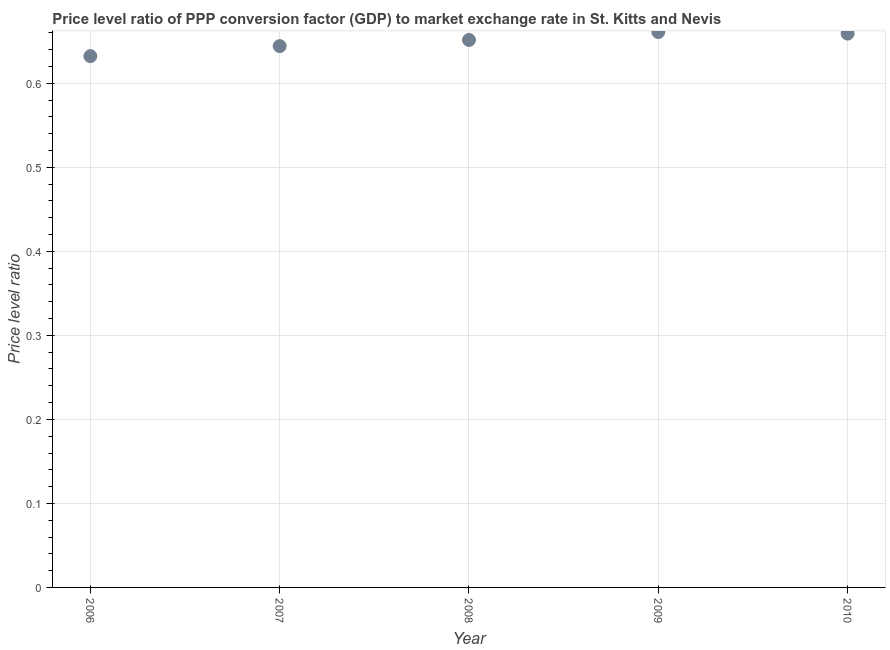What is the price level ratio in 2010?
Offer a very short reply. 0.66. Across all years, what is the maximum price level ratio?
Your answer should be compact. 0.66. Across all years, what is the minimum price level ratio?
Ensure brevity in your answer.  0.63. What is the sum of the price level ratio?
Provide a succinct answer. 3.25. What is the difference between the price level ratio in 2006 and 2007?
Provide a succinct answer. -0.01. What is the average price level ratio per year?
Provide a succinct answer. 0.65. What is the median price level ratio?
Your answer should be compact. 0.65. In how many years, is the price level ratio greater than 0.54 ?
Ensure brevity in your answer.  5. Do a majority of the years between 2006 and 2008 (inclusive) have price level ratio greater than 0.26 ?
Your answer should be compact. Yes. What is the ratio of the price level ratio in 2007 to that in 2008?
Provide a short and direct response. 0.99. Is the price level ratio in 2007 less than that in 2010?
Give a very brief answer. Yes. What is the difference between the highest and the second highest price level ratio?
Ensure brevity in your answer.  0. Is the sum of the price level ratio in 2006 and 2008 greater than the maximum price level ratio across all years?
Your response must be concise. Yes. What is the difference between the highest and the lowest price level ratio?
Your answer should be very brief. 0.03. In how many years, is the price level ratio greater than the average price level ratio taken over all years?
Ensure brevity in your answer.  3. What is the difference between two consecutive major ticks on the Y-axis?
Offer a very short reply. 0.1. Are the values on the major ticks of Y-axis written in scientific E-notation?
Your response must be concise. No. Does the graph contain any zero values?
Provide a short and direct response. No. What is the title of the graph?
Ensure brevity in your answer.  Price level ratio of PPP conversion factor (GDP) to market exchange rate in St. Kitts and Nevis. What is the label or title of the Y-axis?
Provide a succinct answer. Price level ratio. What is the Price level ratio in 2006?
Provide a succinct answer. 0.63. What is the Price level ratio in 2007?
Provide a short and direct response. 0.64. What is the Price level ratio in 2008?
Make the answer very short. 0.65. What is the Price level ratio in 2009?
Provide a succinct answer. 0.66. What is the Price level ratio in 2010?
Offer a very short reply. 0.66. What is the difference between the Price level ratio in 2006 and 2007?
Provide a short and direct response. -0.01. What is the difference between the Price level ratio in 2006 and 2008?
Give a very brief answer. -0.02. What is the difference between the Price level ratio in 2006 and 2009?
Your answer should be compact. -0.03. What is the difference between the Price level ratio in 2006 and 2010?
Keep it short and to the point. -0.03. What is the difference between the Price level ratio in 2007 and 2008?
Keep it short and to the point. -0.01. What is the difference between the Price level ratio in 2007 and 2009?
Your answer should be compact. -0.02. What is the difference between the Price level ratio in 2007 and 2010?
Make the answer very short. -0.01. What is the difference between the Price level ratio in 2008 and 2009?
Give a very brief answer. -0.01. What is the difference between the Price level ratio in 2008 and 2010?
Your answer should be very brief. -0.01. What is the difference between the Price level ratio in 2009 and 2010?
Ensure brevity in your answer.  0. What is the ratio of the Price level ratio in 2006 to that in 2007?
Provide a succinct answer. 0.98. What is the ratio of the Price level ratio in 2006 to that in 2009?
Provide a short and direct response. 0.96. What is the ratio of the Price level ratio in 2006 to that in 2010?
Offer a terse response. 0.96. What is the ratio of the Price level ratio in 2008 to that in 2010?
Your response must be concise. 0.99. What is the ratio of the Price level ratio in 2009 to that in 2010?
Ensure brevity in your answer.  1. 